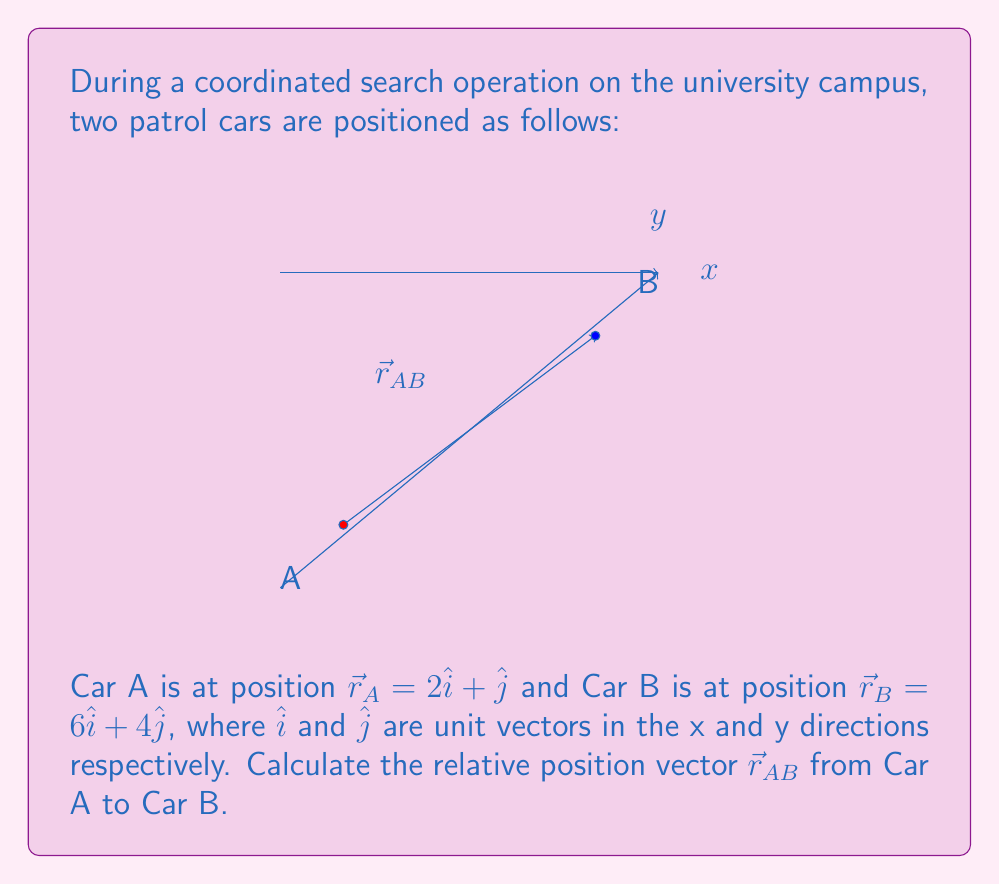Show me your answer to this math problem. To find the relative position vector $\vec{r}_{AB}$ from Car A to Car B, we need to subtract the position vector of Car A from the position vector of Car B. This gives us the displacement vector from A to B.

Step 1: Identify the position vectors
$\vec{r}_A = 2\hat{i} + \hat{j}$
$\vec{r}_B = 6\hat{i} + 4\hat{j}$

Step 2: Calculate $\vec{r}_{AB}$ using vector subtraction
$$\begin{align}
\vec{r}_{AB} &= \vec{r}_B - \vec{r}_A \\
&= (6\hat{i} + 4\hat{j}) - (2\hat{i} + \hat{j}) \\
&= (6\hat{i} - 2\hat{i}) + (4\hat{j} - \hat{j}) \\
&= 4\hat{i} + 3\hat{j}
\end{align}$$

Step 3: Interpret the result
The relative position vector $\vec{r}_{AB} = 4\hat{i} + 3\hat{j}$ indicates that to get from Car A to Car B, one needs to move 4 units in the positive x-direction and 3 units in the positive y-direction.
Answer: $\vec{r}_{AB} = 4\hat{i} + 3\hat{j}$ 